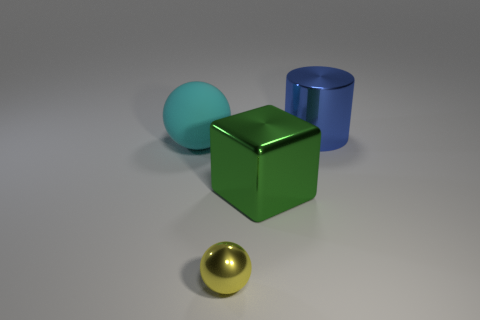What is the shape of the big metal object that is in front of the ball that is behind the green metallic thing?
Provide a short and direct response. Cube. Are there any other small yellow things that have the same material as the yellow thing?
Provide a short and direct response. No. What number of cyan objects are either small things or big matte blocks?
Your answer should be very brief. 0. Is there a large metal cylinder of the same color as the matte thing?
Ensure brevity in your answer.  No. There is a blue object that is the same material as the green object; what is its size?
Your answer should be compact. Large. How many blocks are either blue objects or large cyan things?
Keep it short and to the point. 0. Are there more big cyan spheres than objects?
Offer a terse response. No. What number of objects are the same size as the green metallic block?
Make the answer very short. 2. How many things are either things behind the small yellow ball or brown metal cubes?
Your answer should be very brief. 3. Is the number of tiny metal balls less than the number of small blue metallic cylinders?
Keep it short and to the point. No. 